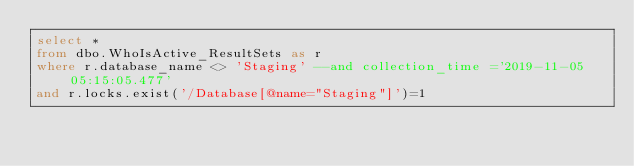Convert code to text. <code><loc_0><loc_0><loc_500><loc_500><_SQL_>select *
from dbo.WhoIsActive_ResultSets as r
where r.database_name <> 'Staging' --and collection_time ='2019-11-05 05:15:05.477'
and r.locks.exist('/Database[@name="Staging"]')=1</code> 